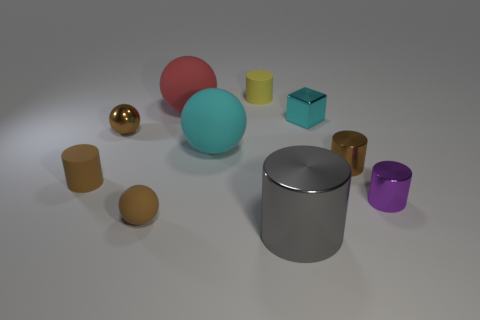What number of other things are there of the same material as the tiny cyan object
Make the answer very short. 4. There is a tiny matte cylinder in front of the small yellow cylinder; is it the same color as the large cylinder?
Ensure brevity in your answer.  No. There is a tiny rubber cylinder that is behind the cyan cube; is there a brown cylinder that is right of it?
Offer a very short reply. Yes. The small cylinder that is to the left of the purple metallic cylinder and to the right of the tiny yellow rubber cylinder is made of what material?
Give a very brief answer. Metal. There is a large cyan thing that is made of the same material as the large red ball; what is its shape?
Ensure brevity in your answer.  Sphere. Are there any other things that have the same shape as the cyan metal thing?
Give a very brief answer. No. Does the small sphere behind the brown shiny cylinder have the same material as the big red ball?
Your response must be concise. No. There is a cyan thing that is right of the yellow cylinder; what is its material?
Offer a terse response. Metal. What size is the rubber cylinder in front of the big rubber object in front of the cyan metallic thing?
Your answer should be very brief. Small. What number of brown cylinders have the same size as the gray metal cylinder?
Offer a terse response. 0. 